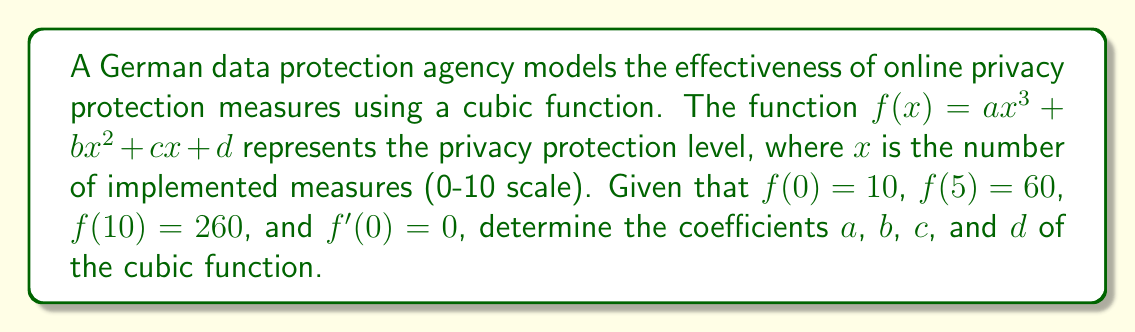Help me with this question. 1) First, we know that $f(0) = 10$, which means $d = 10$.

2) Since $f'(0) = 0$, we know that $c = 0$ (as $f'(x) = 3ax^2 + 2bx + c$).

3) Now we have two equations:
   $f(5) = a(5^3) + b(5^2) + 10 = 60$
   $f(10) = a(10^3) + b(10^2) + 10 = 260$

4) Simplify:
   $125a + 25b = 50$
   $1000a + 100b = 250$

5) Multiply the first equation by 8:
   $1000a + 200b = 400$

6) Subtract this from the second equation:
   $-100b = -150$
   $b = 1.5$

7) Substitute this back into $125a + 25b = 50$:
   $125a + 25(1.5) = 50$
   $125a = 12.5$
   $a = 0.1$

8) Therefore, the cubic function is:
   $f(x) = 0.1x^3 + 1.5x^2 + 10$
Answer: $a = 0.1$, $b = 1.5$, $c = 0$, $d = 10$ 